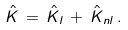Convert formula to latex. <formula><loc_0><loc_0><loc_500><loc_500>\hat { K } \, = \, \hat { K } _ { l } \, + \, \hat { K } _ { n l } \, .</formula> 